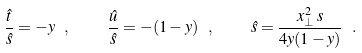Convert formula to latex. <formula><loc_0><loc_0><loc_500><loc_500>\frac { \hat { t } } { \hat { s } } = - y \ , \quad \frac { \hat { u } } { \hat { s } } = - ( 1 - y ) \ , \quad \hat { s } = \frac { x _ { \perp } ^ { 2 } \, s } { 4 y ( 1 - y ) } \ .</formula> 